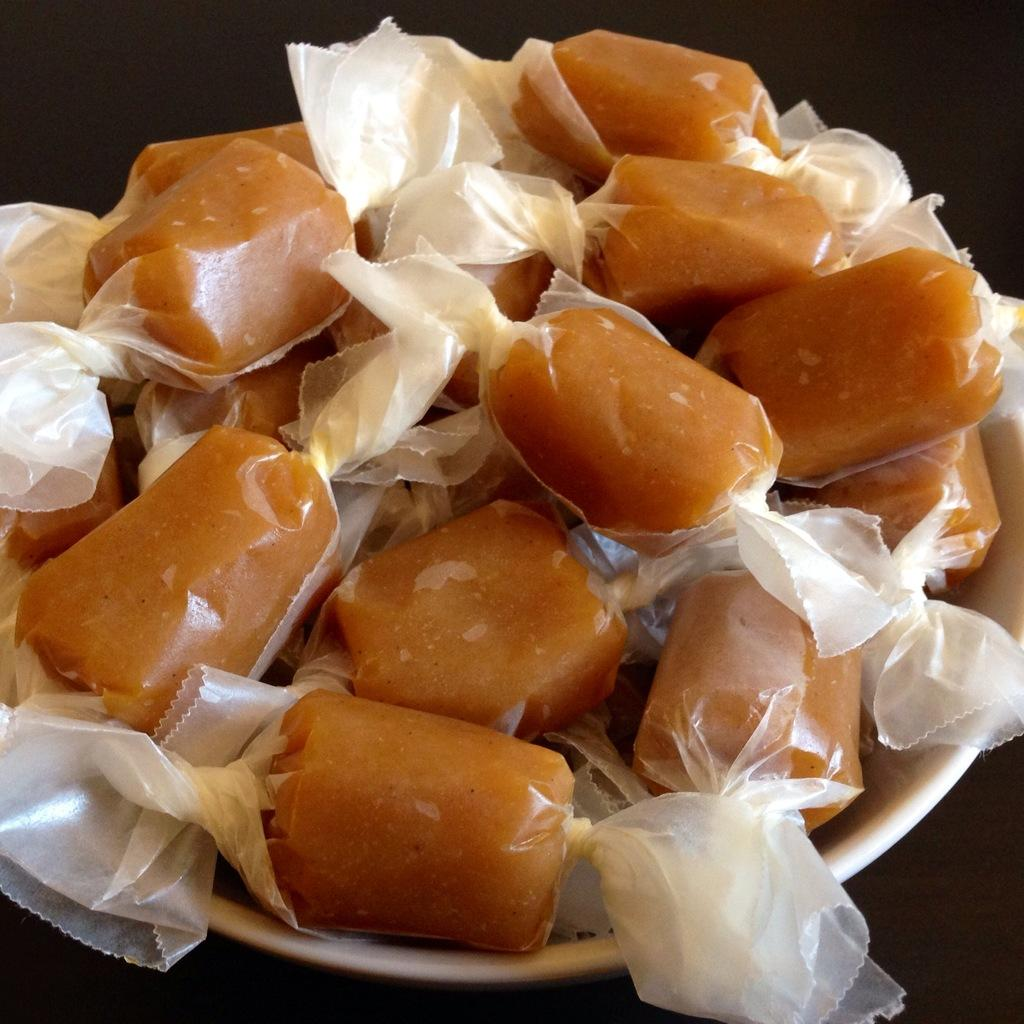What type of items can be seen in the image? There are eatables in the image. How are the eatables contained or protected? The eatables are placed in a cover. What is the color of the bowl that holds the cover? The cover is in a white bowl. Reasoning: Leting: Let's think step by step in order to produce the conversation. We start by identifying the main subject in the image, which is the eatables. Then, we expand the conversation to include the cover that contains the eatables and the color of the bowl that holds the cover. Each question is designed to elicit a specific detail about the image that is known from the provided facts. Absurd Question/Answer: What type of music can be heard coming from the eatables in the image? There is no music associated with the eatables in the image. Can you see a robin perched on the edge of the bowl in the image? There is no robin present in the image. What type of music can be heard coming from the eatables in the image? There is no music associated with the eatables in the image. Can you see a robin perched on the edge of the bowl in the image? There is no robin present in the image. 